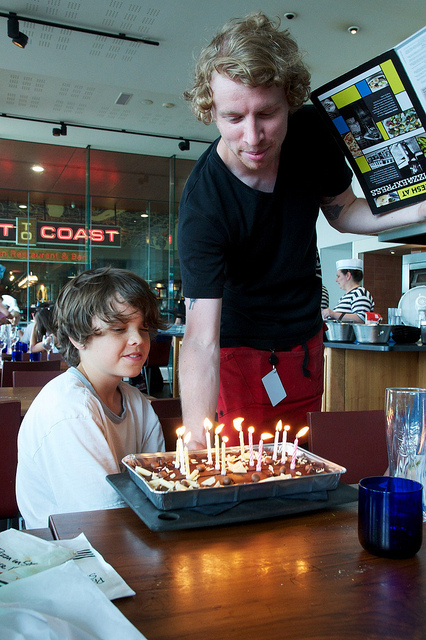<image>What time of year is it? I don't know the exact time of the year, but it might be summer or spring. What time of year is it? I am not sure what time of year it is. It can be either summer or spring. 